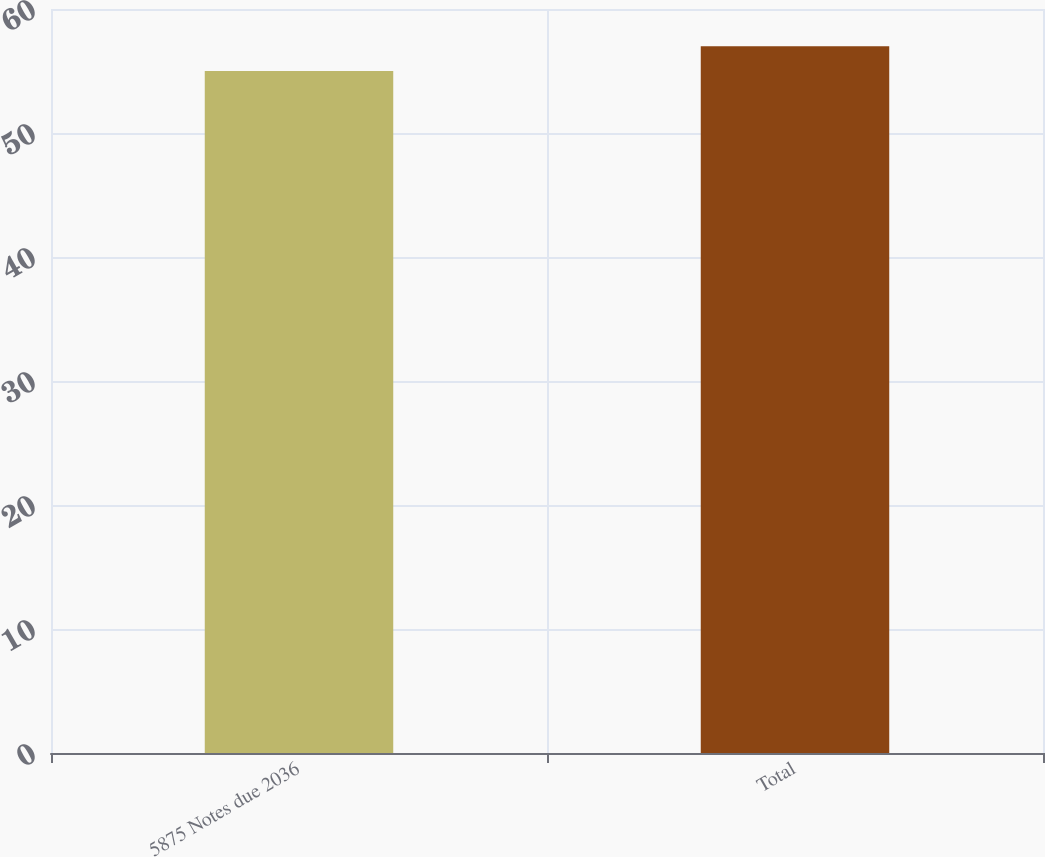Convert chart to OTSL. <chart><loc_0><loc_0><loc_500><loc_500><bar_chart><fcel>5875 Notes due 2036<fcel>Total<nl><fcel>55<fcel>57<nl></chart> 